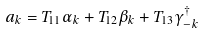<formula> <loc_0><loc_0><loc_500><loc_500>a _ { k } = T _ { 1 1 } \alpha _ { k } + T _ { 1 2 } \beta _ { k } + T _ { 1 3 } \gamma _ { - k } ^ { \dagger }</formula> 